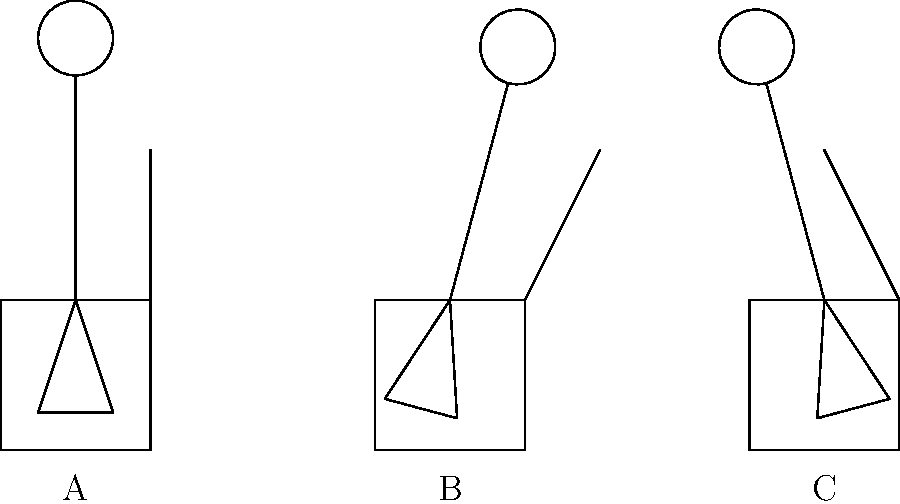As an occupational therapist, which seating position (A, B, or C) would you recommend to promote optimal spinal alignment and posture for a patient recovering from lower back surgery? To answer this question, we need to analyze each seating position and its effect on spinal alignment and posture:

1. Position A:
   - The chair has a 90-degree backrest angle.
   - The person is sitting upright with a neutral spine position.
   - This position maintains the natural curves of the spine.

2. Position B:
   - The chair has a reclined backrest angle.
   - The person's upper body is tilted backward.
   - This position may increase pressure on the lower back and potentially strain the neck.

3. Position C:
   - The chair has a forward-tilting backrest angle.
   - The person's upper body is leaning slightly forward.
   - This position may cause increased pressure on the lower back and lead to hunching.

For a patient recovering from lower back surgery, the primary goal is to maintain proper spinal alignment and reduce stress on the lower back. Position A provides the best support for these objectives because:

1. It maintains the natural curvature of the spine.
2. It distributes body weight evenly across the seat and backrest.
3. It promotes an upright posture without putting excessive strain on any particular part of the back.

While positions B and C might be suitable for specific tasks or short-term use, they are not ideal for prolonged sitting, especially for someone recovering from lower back surgery. Position B may cause the patient to slide forward, increasing pressure on the lower back, while position C may lead to muscle fatigue and potential hunching over time.

Therefore, position A would be the most appropriate recommendation for promoting optimal spinal alignment and posture for a patient recovering from lower back surgery.
Answer: Position A 